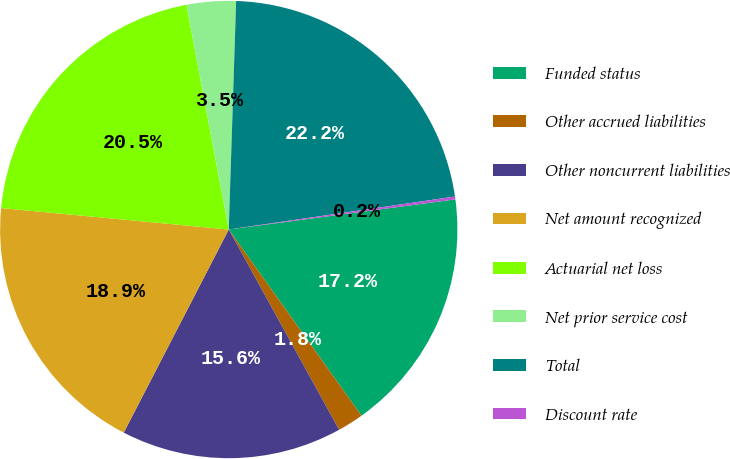Convert chart. <chart><loc_0><loc_0><loc_500><loc_500><pie_chart><fcel>Funded status<fcel>Other accrued liabilities<fcel>Other noncurrent liabilities<fcel>Net amount recognized<fcel>Actuarial net loss<fcel>Net prior service cost<fcel>Total<fcel>Discount rate<nl><fcel>17.25%<fcel>1.84%<fcel>15.61%<fcel>18.9%<fcel>20.54%<fcel>3.48%<fcel>22.18%<fcel>0.2%<nl></chart> 